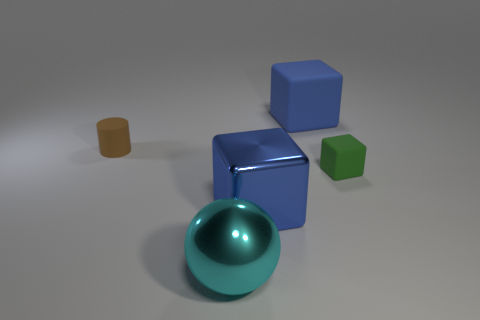Are there fewer small rubber cylinders that are on the right side of the big shiny block than matte things in front of the small brown rubber cylinder?
Ensure brevity in your answer.  Yes. What number of other objects are there of the same shape as the big cyan shiny thing?
Your answer should be compact. 0. Are there fewer cyan shiny balls that are left of the tiny green matte thing than gray shiny objects?
Your response must be concise. No. What is the small object that is to the left of the big cyan object made of?
Ensure brevity in your answer.  Rubber. What number of other objects are there of the same size as the matte cylinder?
Give a very brief answer. 1. Are there fewer large cyan cubes than large cyan things?
Offer a terse response. Yes. There is a large blue matte thing; what shape is it?
Your answer should be compact. Cube. Do the rubber object behind the cylinder and the big shiny cube have the same color?
Give a very brief answer. Yes. The large thing that is both right of the big cyan thing and in front of the tiny cylinder has what shape?
Your response must be concise. Cube. There is a big object that is behind the blue metallic cube; what color is it?
Your answer should be compact. Blue. 